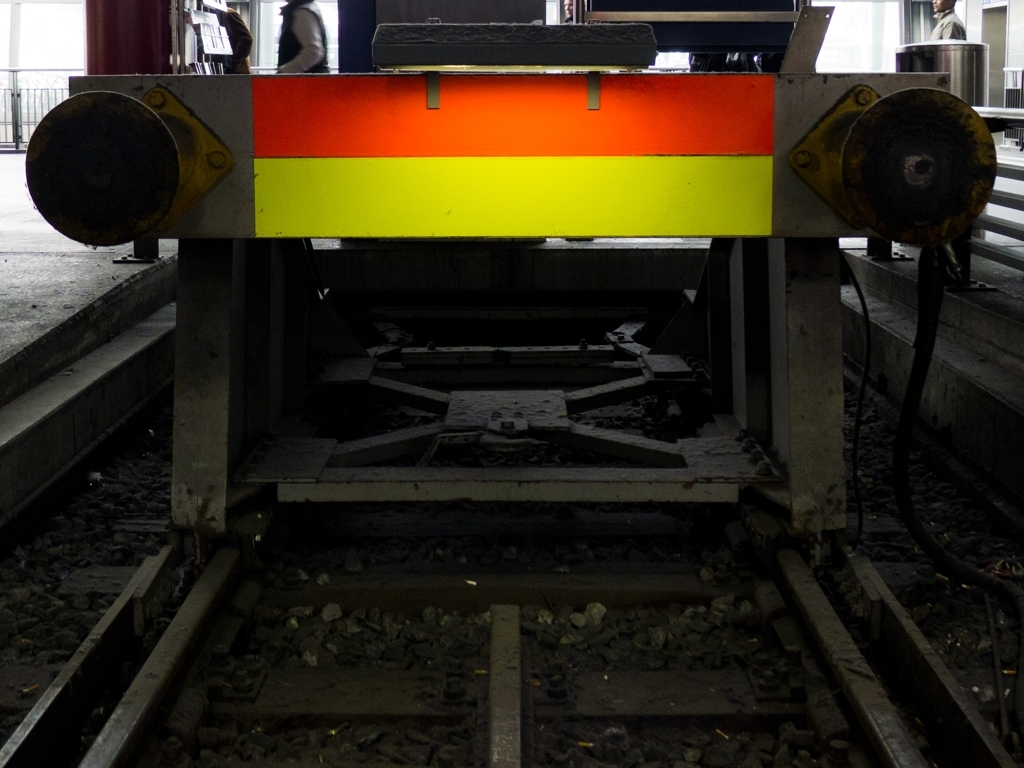What is clear in this image despite the dark environment?
A. hills and mountains
B. trees and foliage
C. track and gravel
D. clouds and sky
Answer with the option's letter from the given choices directly.
 Although the image is taken in a dimly lit environment, the clearest details that can be discerned are those related to option C, which includes the track and gravel. This can be seen in the foreground of the image, indicating the presence of a railway or tramway environment where the tracks provide a pathway for vehicles and are typically lined with gravel. The presence and condition of the tracks and gravel are important for the safe operation of trains or trams, making this a significant aspect of the image. 